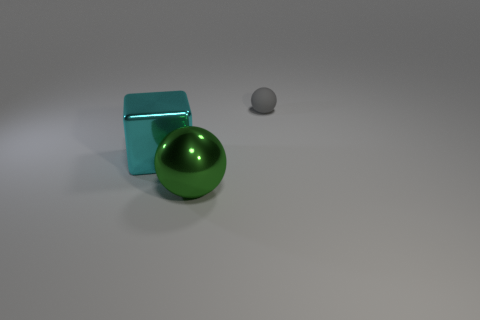Can you describe the lighting in the scene? The lighting in the scene is soft and diffused, with the source likely positioned above the objects, creating gentle shadows and subtle highlights on the surfaces. 